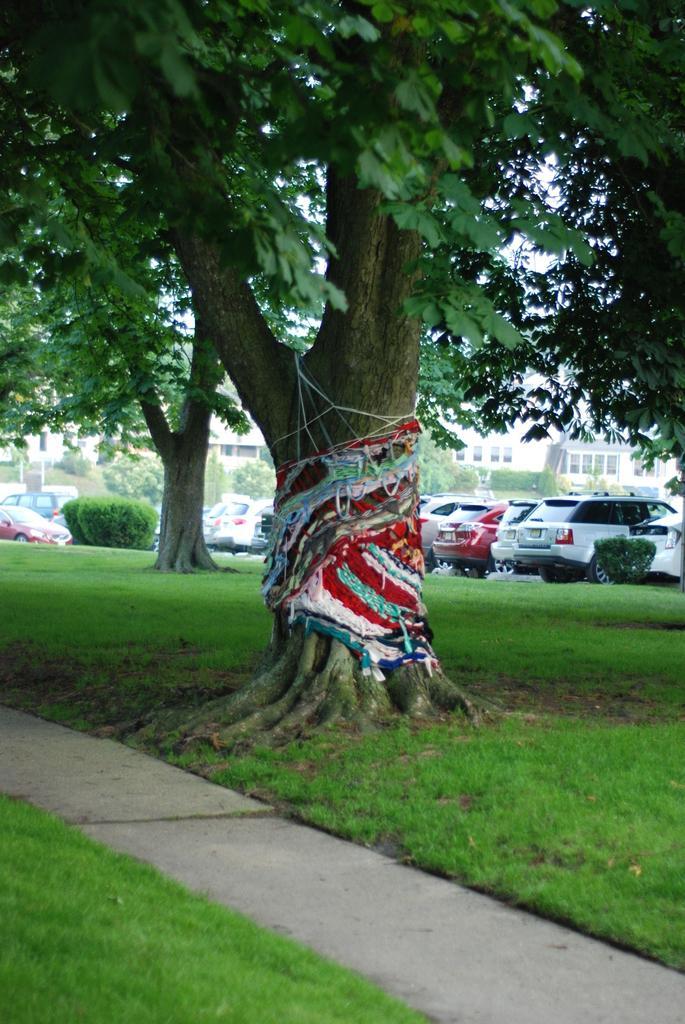Please provide a concise description of this image. In this image, we can see buildings, vehicles, shrubs and there are trees and we can see some clothes on one of the tree. At the bottom, there is ground. 